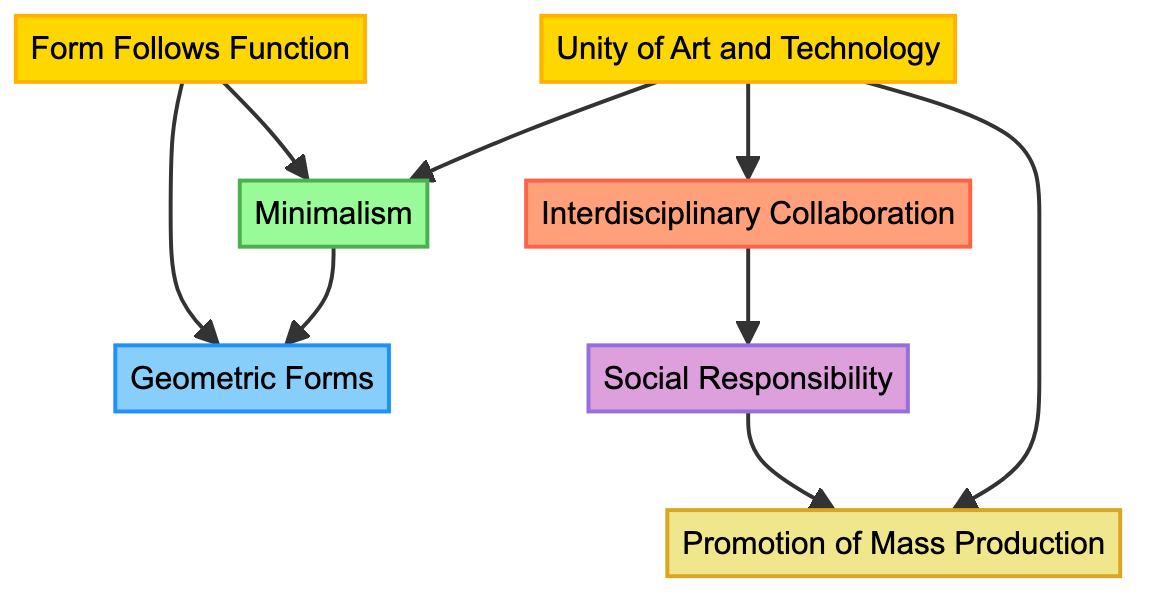What is the top concept in the flowchart? The flowchart starts with the first concept, which is "Form Follows Function." Thus, this is the top concept that represents a foundational principle in Bauhaus design.
Answer: Form Follows Function How many design elements are represented in the flowchart? The flowchart includes one specific design element, which is "Geometric Forms." It can be identified as a node in the diagram under the category of Design Element.
Answer: 1 Which concepts lead to Minimalism? In the flowchart, "Form Follows Function" and "Unity of Art and Technology" both have direct connections to "Minimalism," indicating that both concepts contribute to or support the idea of Minimalism in design.
Answer: Form Follows Function, Unity of Art and Technology What type of practice promotes Social Responsibility? The flowchart indicates that "Interdisciplinary Collaboration" leads to "Social Responsibility." This signifies that practicing collaboration in various fields encourages designers to think about their societal impact.
Answer: Interdisciplinary Collaboration Which design approach is associated with both Geometric Forms and Minimalism? The flowchart shows that "Geometric Forms" is directly connected to "Minimalism," indicating that the emphasis on simple forms aligns with the minimalist design approach.
Answer: Minimalism What is the relationship between Unity of Art and Technology and Promotion of Mass Production? In the flowchart, "Unity of Art and Technology" has a direct link to "Promotion of Mass Production." This suggests that the integration of art and technology supports the goal of creating designs suitable for mass production.
Answer: Direct link What are the last two nodes in the flowchart? The flowchart concludes with two nodes: "Social Responsibility" and "Promotion of Mass Production." These represent key principles that arise from the design ethos and economic considerations in Bauhaus philosophy.
Answer: Social Responsibility, Promotion of Mass Production How does Minimalism connect with Geometric Forms? The flowchart illustrates that "Minimalism" directly leads to "Geometric Forms," demonstrating that the minimalist approach emphasizes the use of simple geometric shapes in design.
Answer: Direct connection What is the design ethos depicted in the chart? The flowchart identifies "Social Responsibility" as the design ethos, emphasizing the belief that design should serve society. This aspect informs the values within the Bauhaus movement.
Answer: Social Responsibility 